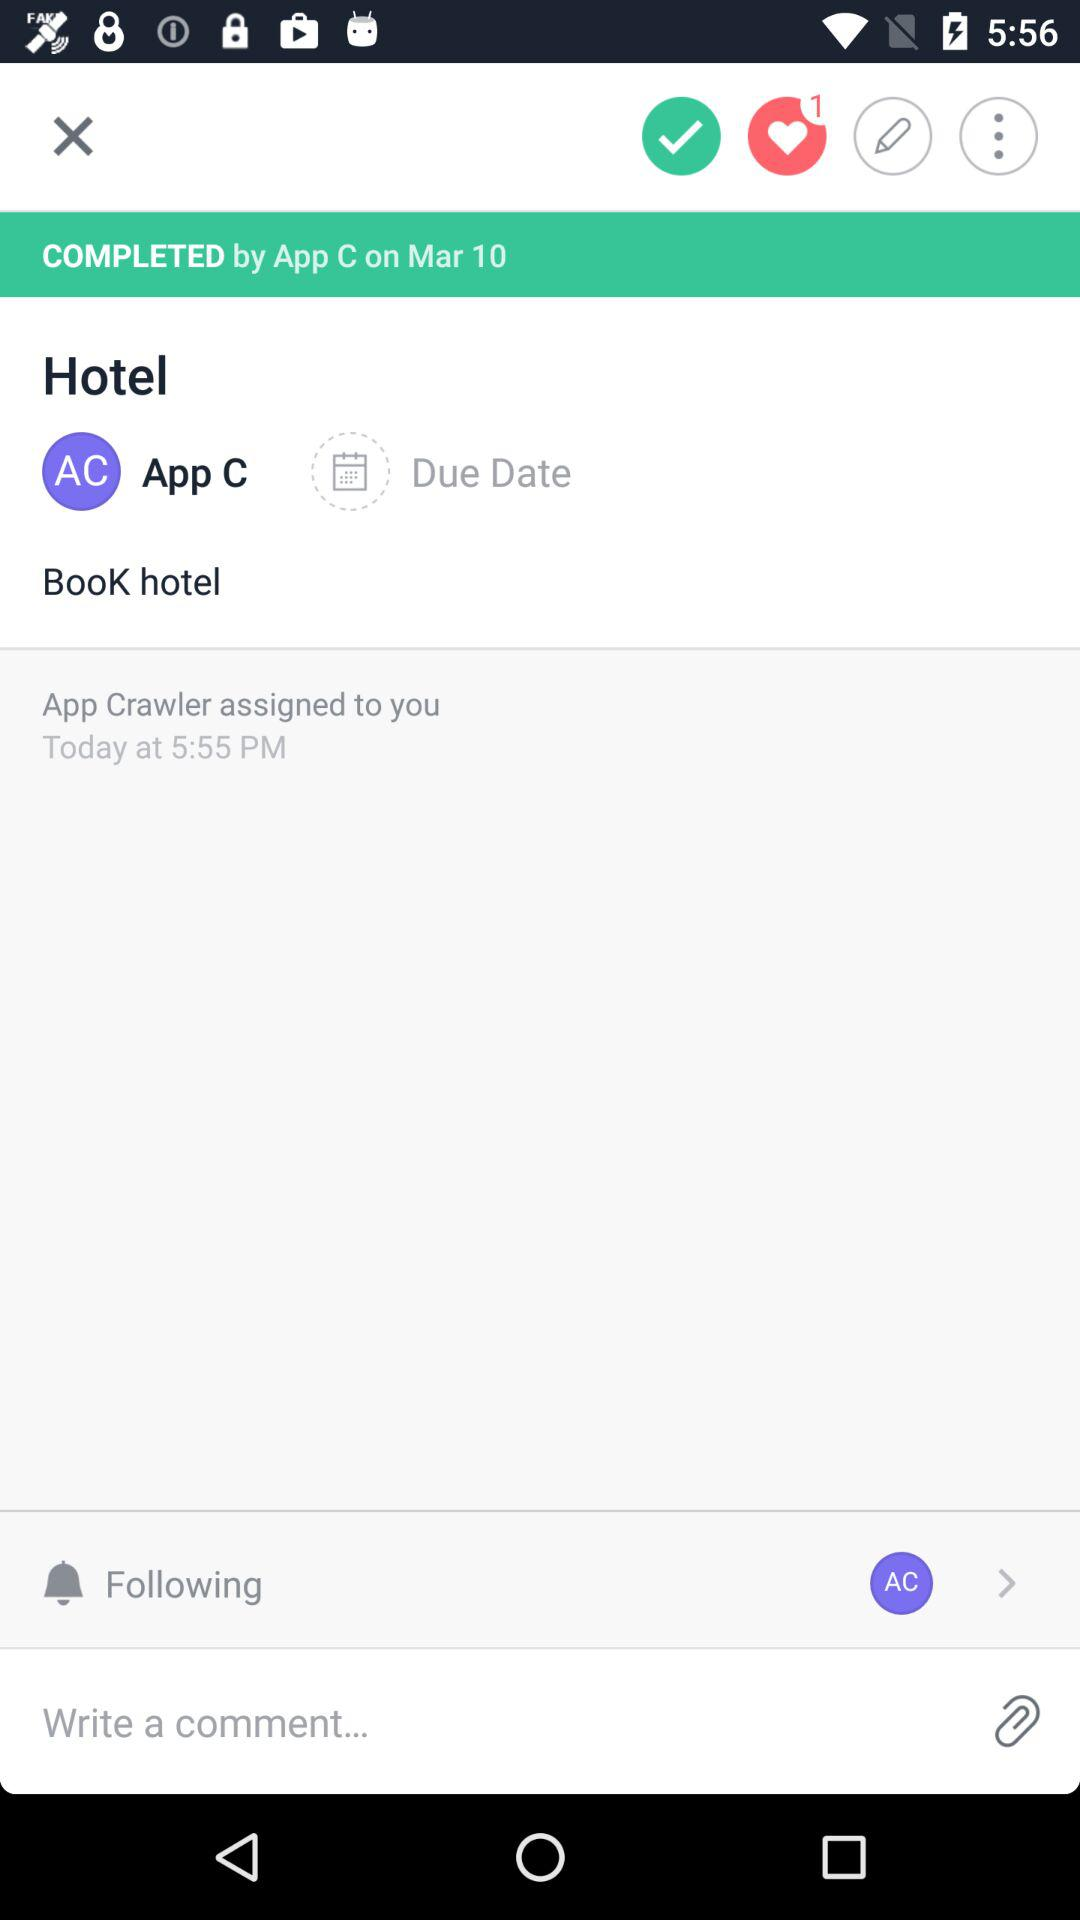How many notifications are there?
Answer the question using a single word or phrase. 1 